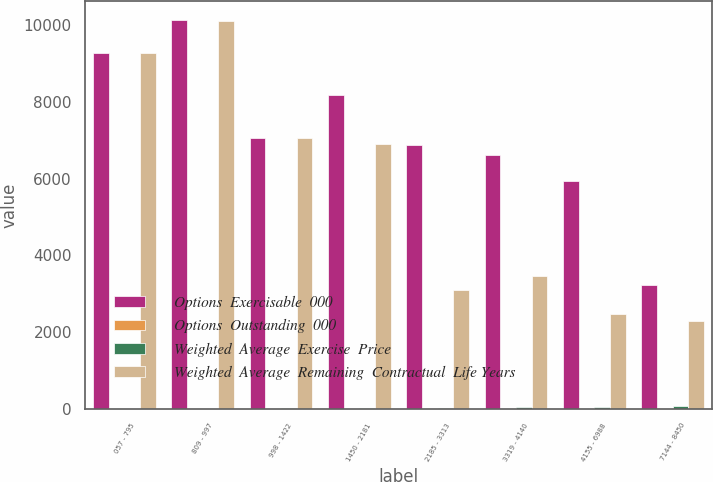Convert chart. <chart><loc_0><loc_0><loc_500><loc_500><stacked_bar_chart><ecel><fcel>057 - 795<fcel>809 - 997<fcel>998 - 1422<fcel>1450 - 2181<fcel>2185 - 3313<fcel>3319 - 4140<fcel>4155 - 6988<fcel>7144 - 8450<nl><fcel>Options  Exercisable  000<fcel>9269<fcel>10128<fcel>7054<fcel>8190<fcel>6871<fcel>6620<fcel>5944<fcel>3229<nl><fcel>Options  Outstanding  000<fcel>2.01<fcel>4.37<fcel>4.15<fcel>6.46<fcel>8.12<fcel>7.9<fcel>8.28<fcel>7.11<nl><fcel>Weighted  Average  Exercise  Price<fcel>5.77<fcel>9.35<fcel>11.94<fcel>20.7<fcel>30.9<fcel>37.74<fcel>47.87<fcel>77.61<nl><fcel>Weighted  Average  Remaining  Contractual  Life Years<fcel>9269<fcel>10120<fcel>7052<fcel>6908<fcel>3113<fcel>3457<fcel>2482<fcel>2283<nl></chart> 